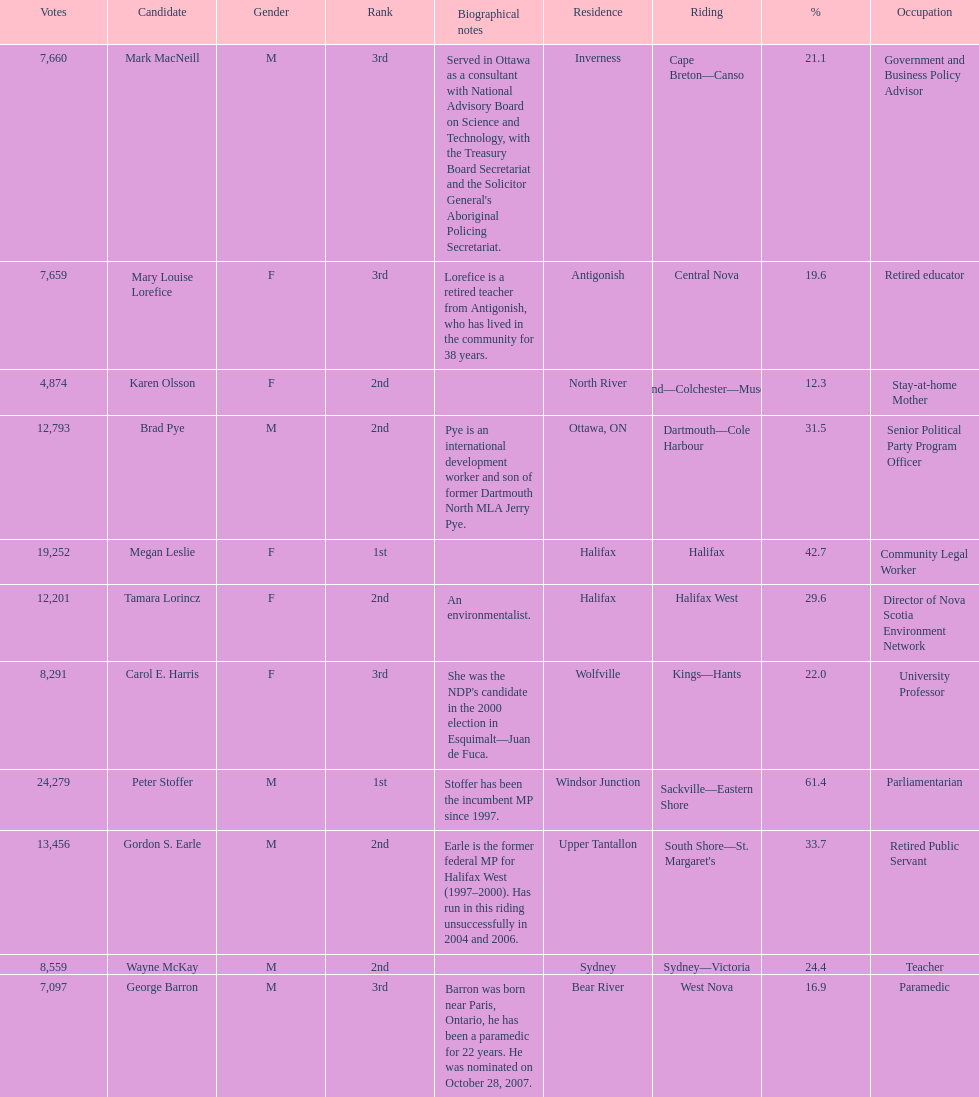How many candidates were from halifax? 2. 